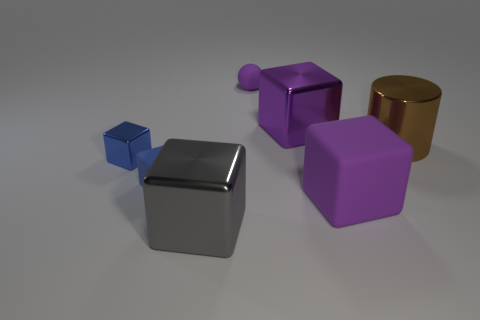There is a gray metal block; how many tiny purple things are in front of it?
Ensure brevity in your answer.  0. Do the big purple block that is behind the big brown metal cylinder and the brown cylinder that is behind the small shiny cube have the same material?
Make the answer very short. Yes. The big purple metal thing that is behind the big metallic object right of the big shiny cube that is to the right of the big gray thing is what shape?
Your response must be concise. Cube. The gray metal thing has what shape?
Give a very brief answer. Cube. What is the shape of the brown thing that is the same size as the gray cube?
Make the answer very short. Cylinder. How many other objects are the same color as the metallic cylinder?
Provide a succinct answer. 0. There is a small rubber object that is in front of the large brown metal thing; does it have the same shape as the small matte object behind the brown metallic object?
Provide a short and direct response. No. What number of things are large objects that are in front of the big metal cylinder or tiny rubber objects on the left side of the ball?
Keep it short and to the point. 3. What number of other things are made of the same material as the brown object?
Your answer should be very brief. 3. Is the material of the purple cube that is behind the tiny metallic thing the same as the large brown cylinder?
Offer a terse response. Yes. 